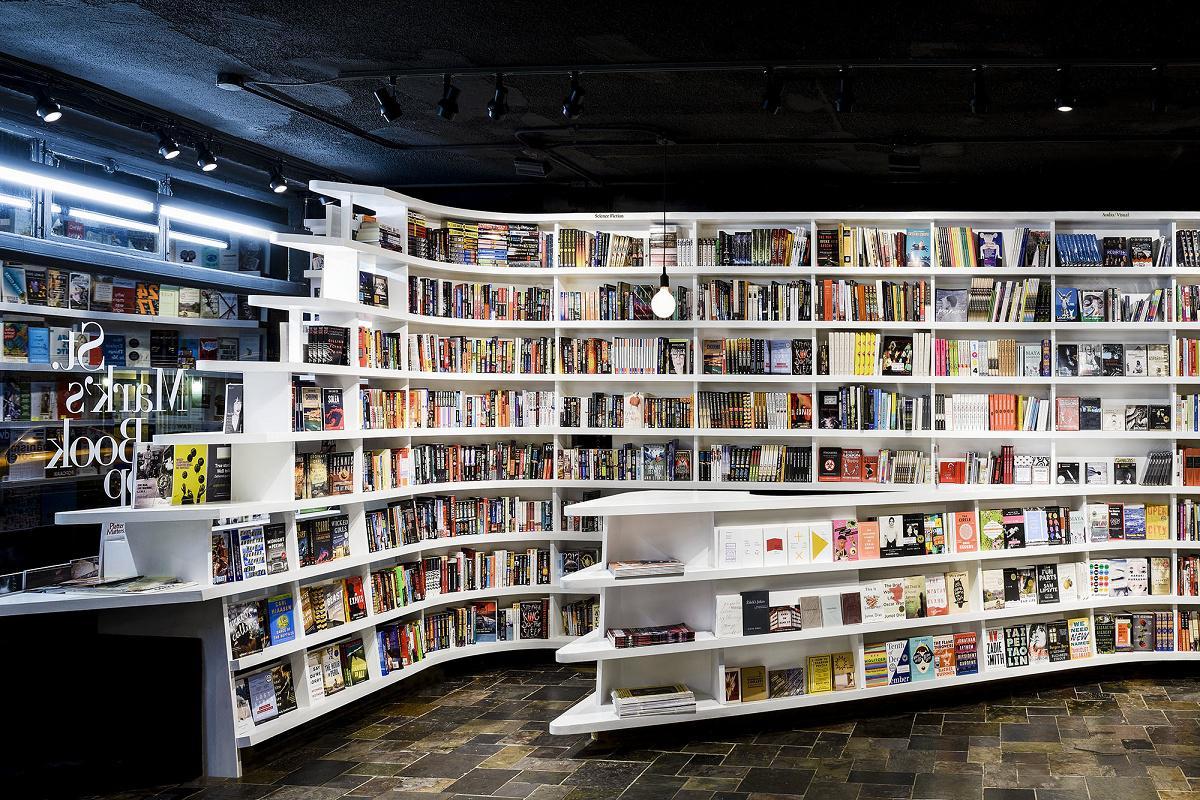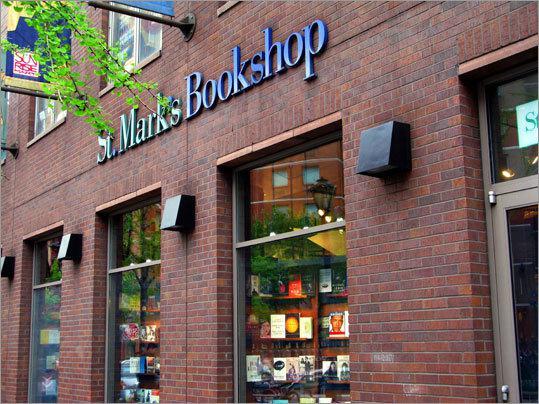The first image is the image on the left, the second image is the image on the right. Given the left and right images, does the statement "There are people looking at and reading books" hold true? Answer yes or no. No. The first image is the image on the left, the second image is the image on the right. Considering the images on both sides, is "All photos show only the exterior facade of the building." valid? Answer yes or no. No. 